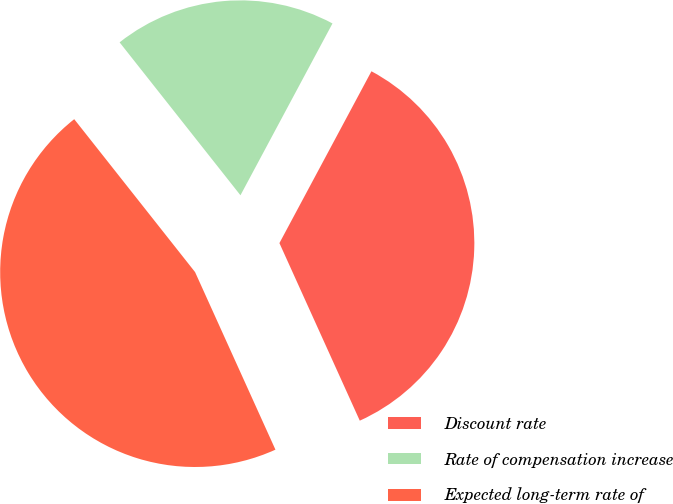Convert chart to OTSL. <chart><loc_0><loc_0><loc_500><loc_500><pie_chart><fcel>Discount rate<fcel>Rate of compensation increase<fcel>Expected long-term rate of<nl><fcel>35.41%<fcel>18.47%<fcel>46.12%<nl></chart> 